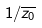Convert formula to latex. <formula><loc_0><loc_0><loc_500><loc_500>1 / \overline { z _ { 0 } }</formula> 